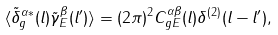Convert formula to latex. <formula><loc_0><loc_0><loc_500><loc_500>\langle \tilde { \delta } _ { g } ^ { \alpha \ast } ( { l } ) \tilde { \gamma } ^ { \beta } _ { E } ( { l } ^ { \prime } ) \rangle = ( 2 \pi ) ^ { 2 } C _ { g E } ^ { \alpha \beta } ( l ) \delta ^ { ( 2 ) } ( { l } - { l } ^ { \prime } ) ,</formula> 